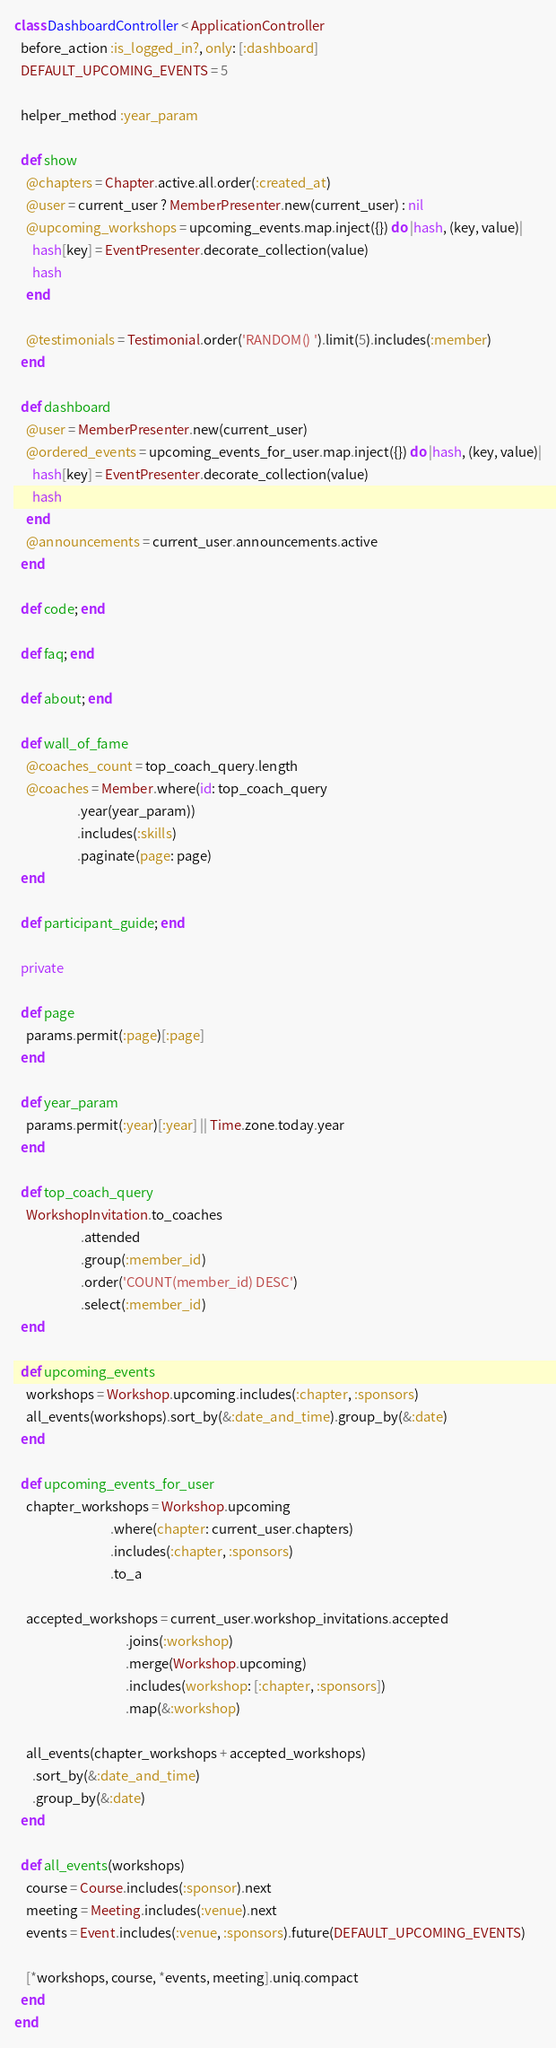<code> <loc_0><loc_0><loc_500><loc_500><_Ruby_>class DashboardController < ApplicationController
  before_action :is_logged_in?, only: [:dashboard]
  DEFAULT_UPCOMING_EVENTS = 5

  helper_method :year_param

  def show
    @chapters = Chapter.active.all.order(:created_at)
    @user = current_user ? MemberPresenter.new(current_user) : nil
    @upcoming_workshops = upcoming_events.map.inject({}) do |hash, (key, value)|
      hash[key] = EventPresenter.decorate_collection(value)
      hash
    end

    @testimonials = Testimonial.order('RANDOM() ').limit(5).includes(:member)
  end

  def dashboard
    @user = MemberPresenter.new(current_user)
    @ordered_events = upcoming_events_for_user.map.inject({}) do |hash, (key, value)|
      hash[key] = EventPresenter.decorate_collection(value)
      hash
    end
    @announcements = current_user.announcements.active
  end

  def code; end

  def faq; end

  def about; end

  def wall_of_fame
    @coaches_count = top_coach_query.length
    @coaches = Member.where(id: top_coach_query
                     .year(year_param))
                     .includes(:skills)
                     .paginate(page: page)
  end

  def participant_guide; end

  private

  def page
    params.permit(:page)[:page]
  end

  def year_param
    params.permit(:year)[:year] || Time.zone.today.year
  end

  def top_coach_query
    WorkshopInvitation.to_coaches
                      .attended
                      .group(:member_id)
                      .order('COUNT(member_id) DESC')
                      .select(:member_id)
  end

  def upcoming_events
    workshops = Workshop.upcoming.includes(:chapter, :sponsors)
    all_events(workshops).sort_by(&:date_and_time).group_by(&:date)
  end

  def upcoming_events_for_user
    chapter_workshops = Workshop.upcoming
                                .where(chapter: current_user.chapters)
                                .includes(:chapter, :sponsors)
                                .to_a

    accepted_workshops = current_user.workshop_invitations.accepted
                                     .joins(:workshop)
                                     .merge(Workshop.upcoming)
                                     .includes(workshop: [:chapter, :sponsors])
                                     .map(&:workshop)

    all_events(chapter_workshops + accepted_workshops)
      .sort_by(&:date_and_time)
      .group_by(&:date)
  end

  def all_events(workshops)
    course = Course.includes(:sponsor).next
    meeting = Meeting.includes(:venue).next
    events = Event.includes(:venue, :sponsors).future(DEFAULT_UPCOMING_EVENTS)

    [*workshops, course, *events, meeting].uniq.compact
  end
end
</code> 